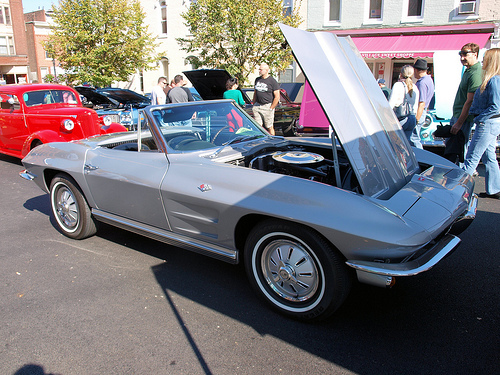<image>
Is there a car next to the window? No. The car is not positioned next to the window. They are located in different areas of the scene. 